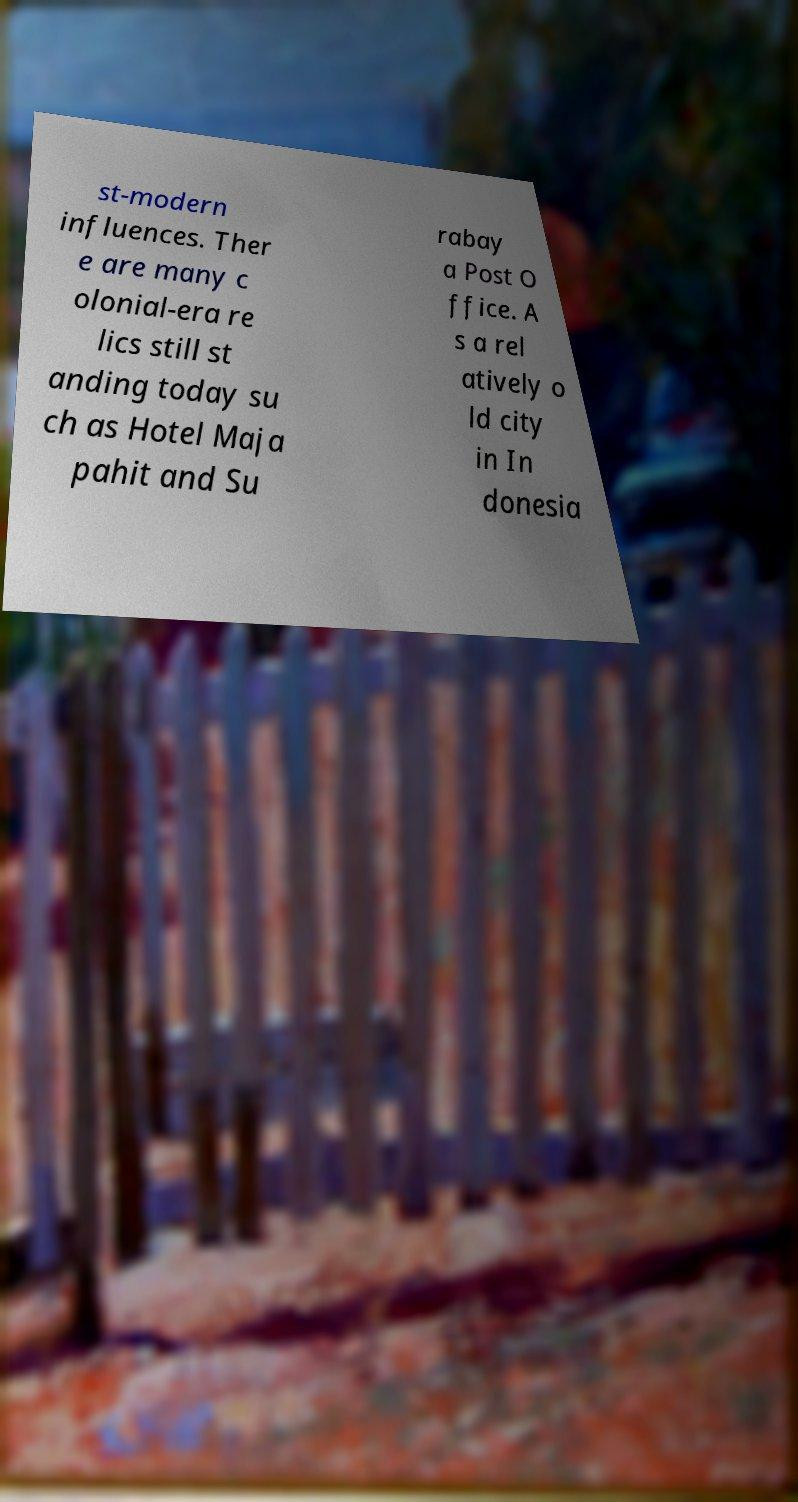Can you accurately transcribe the text from the provided image for me? st-modern influences. Ther e are many c olonial-era re lics still st anding today su ch as Hotel Maja pahit and Su rabay a Post O ffice. A s a rel atively o ld city in In donesia 